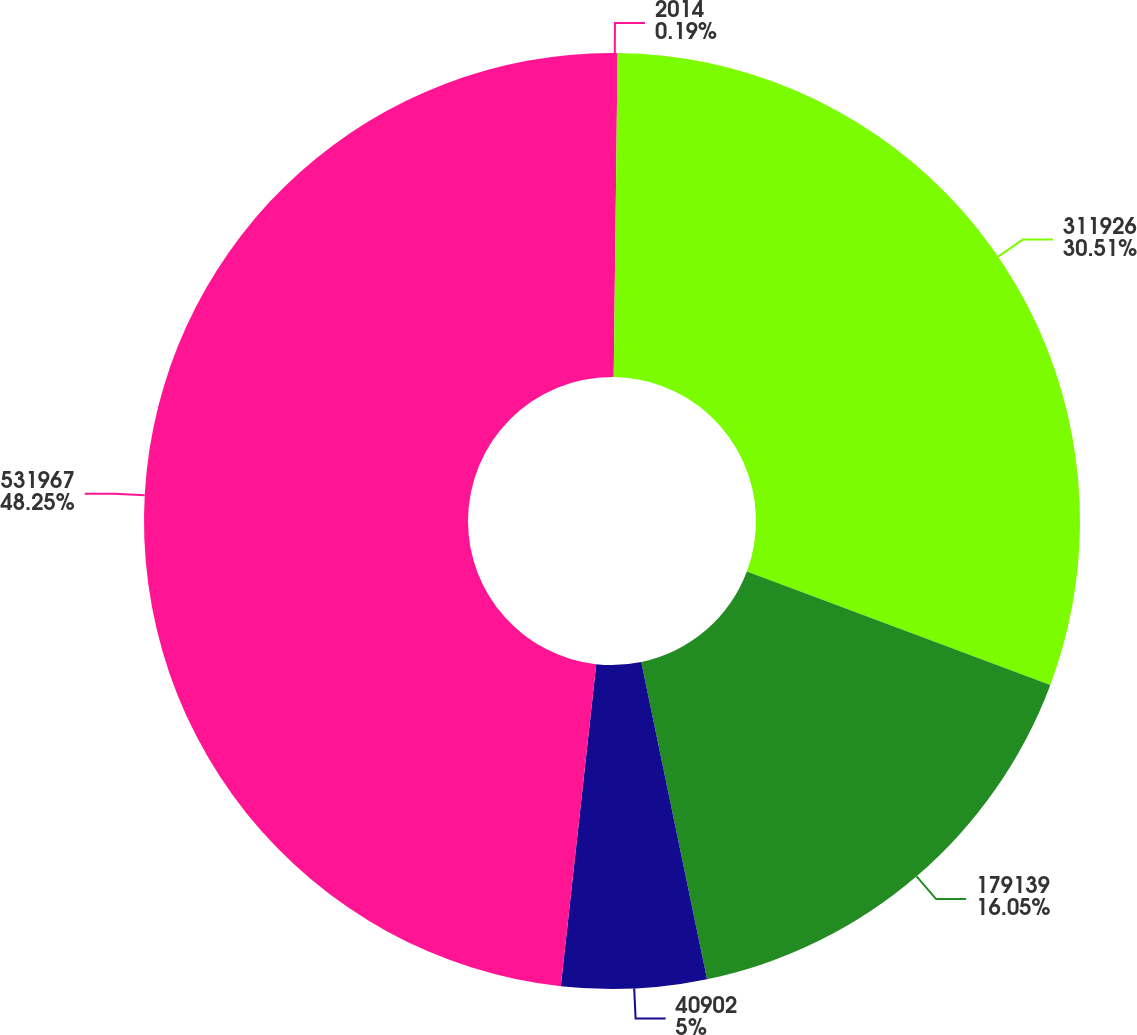<chart> <loc_0><loc_0><loc_500><loc_500><pie_chart><fcel>2014<fcel>311926<fcel>179139<fcel>40902<fcel>531967<nl><fcel>0.19%<fcel>30.51%<fcel>16.05%<fcel>5.0%<fcel>48.26%<nl></chart> 